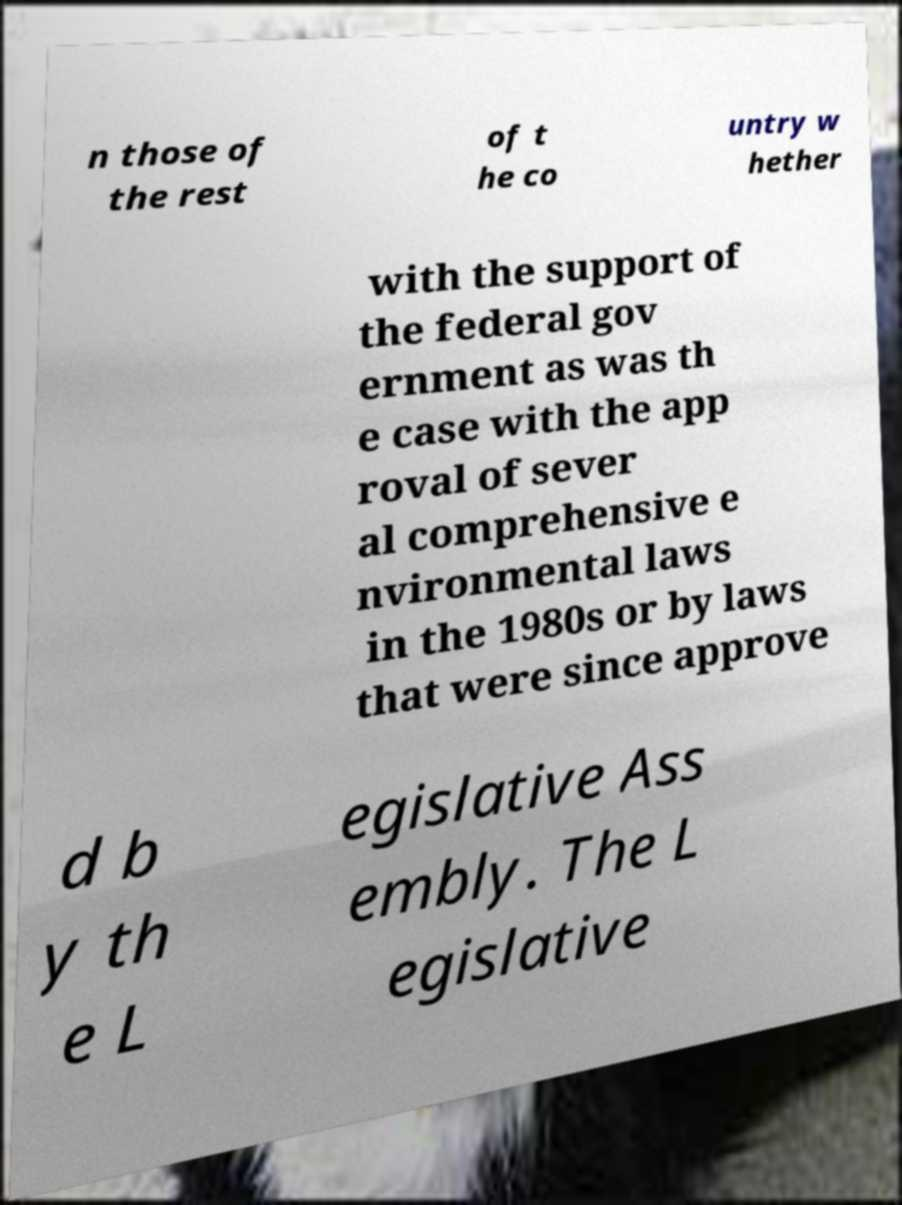There's text embedded in this image that I need extracted. Can you transcribe it verbatim? n those of the rest of t he co untry w hether with the support of the federal gov ernment as was th e case with the app roval of sever al comprehensive e nvironmental laws in the 1980s or by laws that were since approve d b y th e L egislative Ass embly. The L egislative 